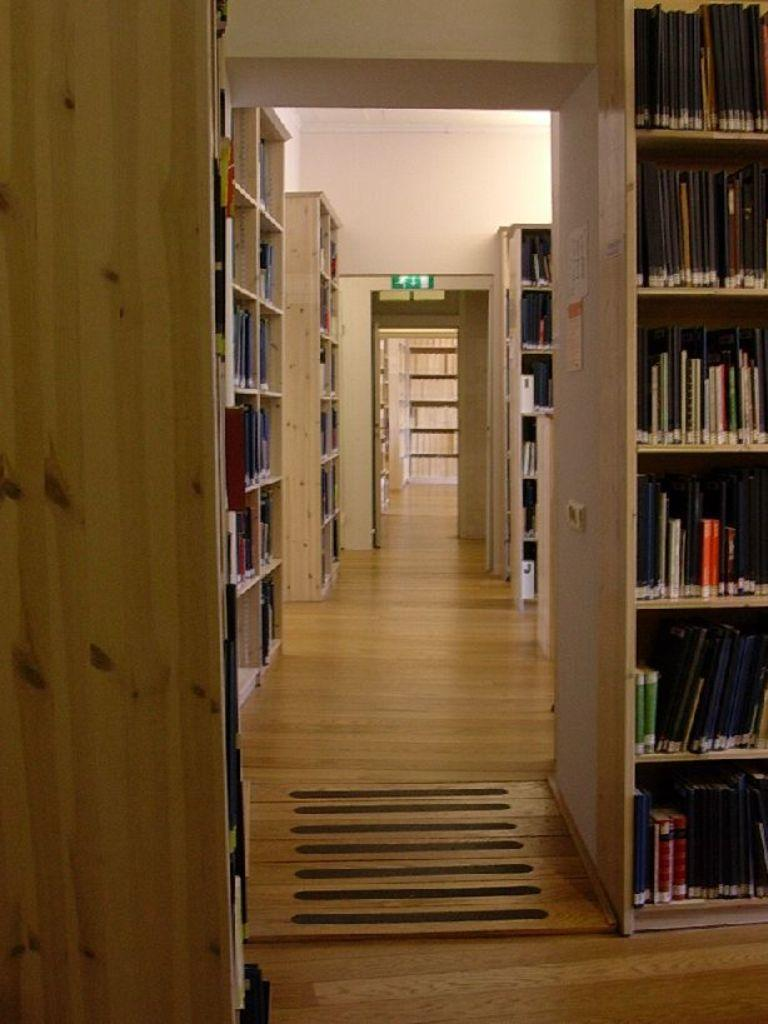What type of establishment is shown in the image? The image depicts a view of a library. Can you describe any specific furniture or objects in the image? There is a wooden wardrobe in the image. What is the purpose of the wardrobe in the library? The wardrobe is full of books. What is the taste of the rock in the image? There is no rock present in the image, and therefore no taste can be attributed to it. 